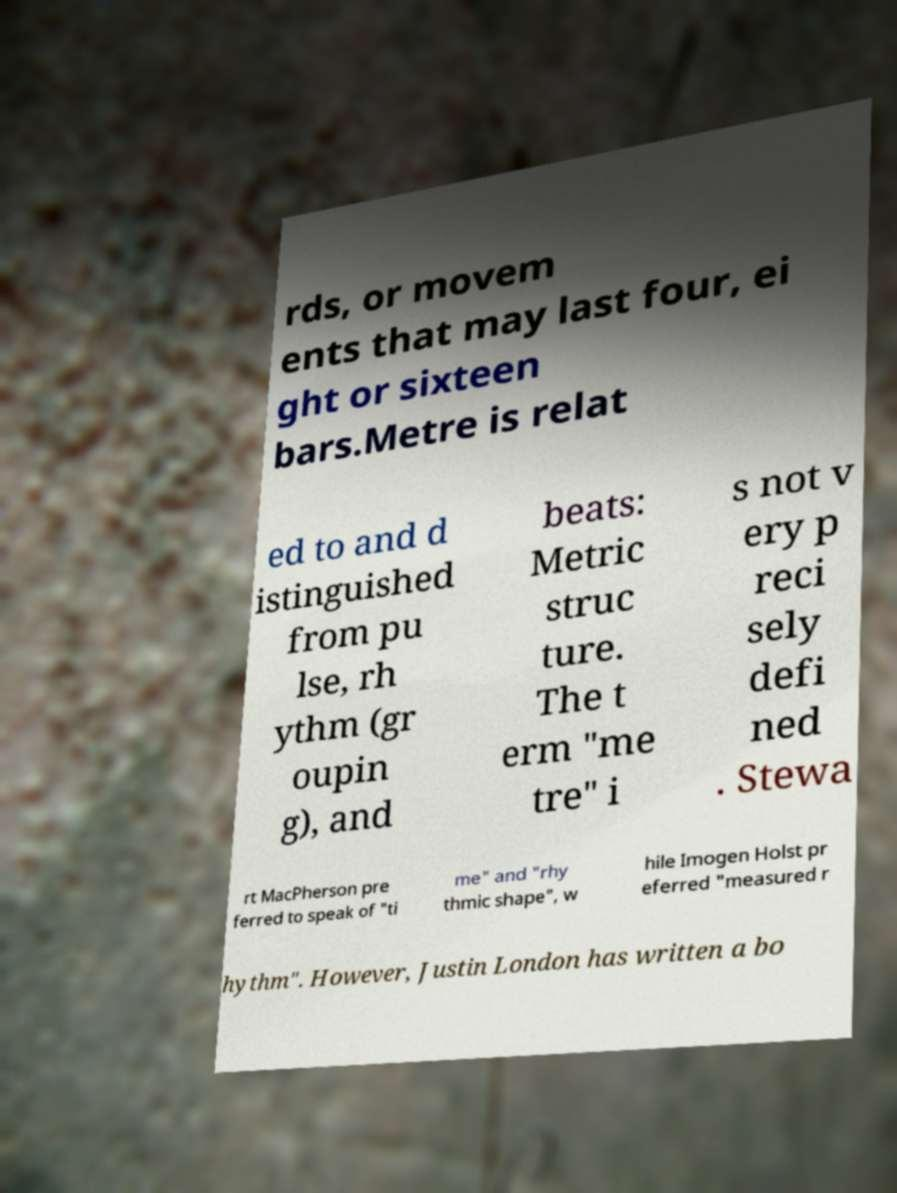There's text embedded in this image that I need extracted. Can you transcribe it verbatim? rds, or movem ents that may last four, ei ght or sixteen bars.Metre is relat ed to and d istinguished from pu lse, rh ythm (gr oupin g), and beats: Metric struc ture. The t erm "me tre" i s not v ery p reci sely defi ned . Stewa rt MacPherson pre ferred to speak of "ti me" and "rhy thmic shape", w hile Imogen Holst pr eferred "measured r hythm". However, Justin London has written a bo 